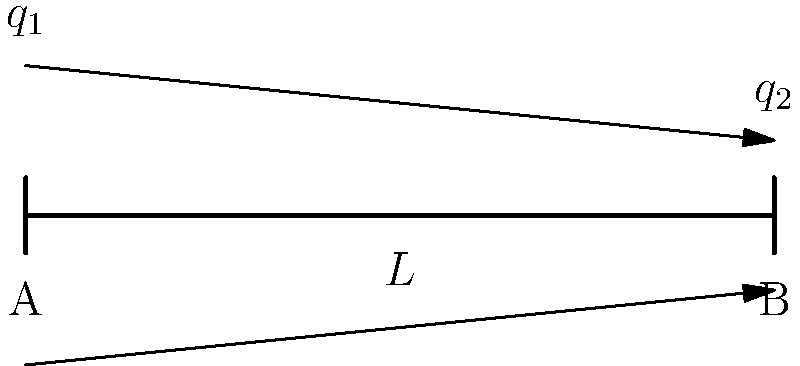In a scene from the popular German engineering drama "Der Ingenieur", a character is analyzing a simply supported beam of length $L$ with a linearly varying distributed load. The load intensity varies from $q_1$ at the left end to $q_2$ at the right end. Determine the maximum bending moment in the beam. Let's approach this step-by-step:

1) First, we need to find the equivalent uniformly distributed load:
   $q_{eq} = \frac{q_1 + q_2}{2}$

2) The total load on the beam is:
   $W = q_{eq} \cdot L = \frac{q_1 + q_2}{2} \cdot L$

3) For a simply supported beam, the reaction forces at the supports are equal:
   $R_A = R_B = \frac{W}{2} = \frac{(q_1 + q_2)L}{4}$

4) The location of the maximum bending moment for a linearly varying load is not at the center, but slightly shifted towards the heavier end. The exact location is given by:

   $x = L \cdot \frac{\sqrt{2q_1 + q_2} - \sqrt{q_1 + 2q_2}}{\sqrt{2q_1 + q_2} + \sqrt{q_1 + 2q_2}}$

5) However, for the maximum bending moment, we can use a simplified formula:
   $M_{max} = \frac{WL}{8} + \frac{(q_1 - q_2)L^2}{60}$

6) Substituting the value of $W$:
   $M_{max} = \frac{(q_1 + q_2)L^2}{16} + \frac{(q_1 - q_2)L^2}{60}$

7) Simplifying:
   $M_{max} = \frac{5(q_1 + q_2)L^2}{80} + \frac{(q_1 - q_2)L^2}{60}$
   $M_{max} = \frac{L^2}{240}(15q_1 + 15q_2 + 4q_1 - 4q_2)$
   $M_{max} = \frac{L^2}{240}(19q_1 + 11q_2)$

This is the formula for the maximum bending moment in the beam.
Answer: $M_{max} = \frac{L^2}{240}(19q_1 + 11q_2)$ 